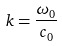<formula> <loc_0><loc_0><loc_500><loc_500>k = \frac { \omega _ { 0 } } { c _ { 0 } }</formula> 